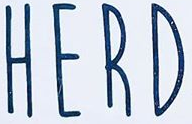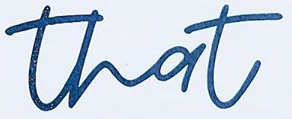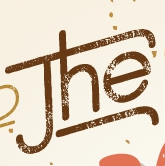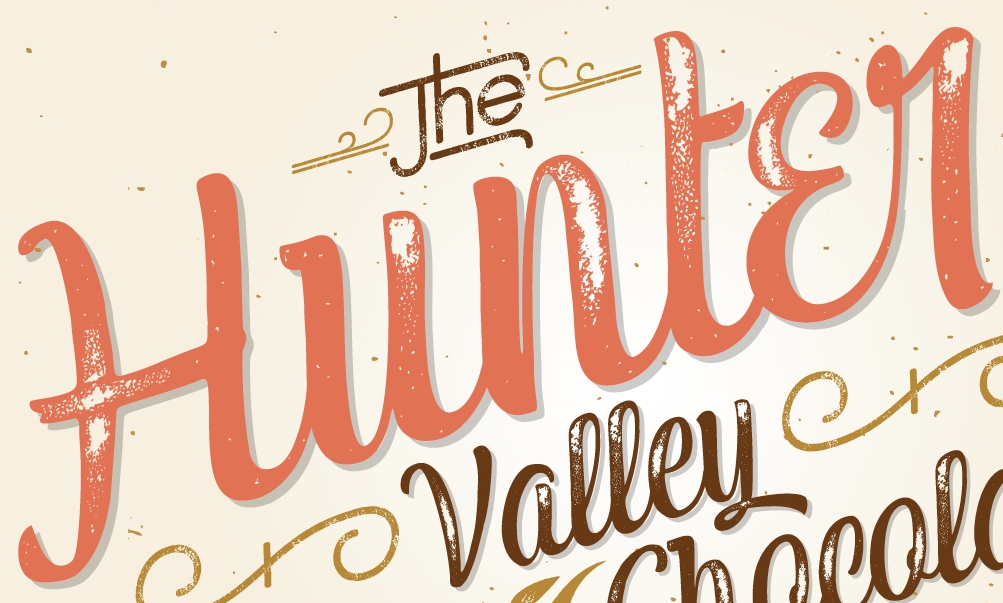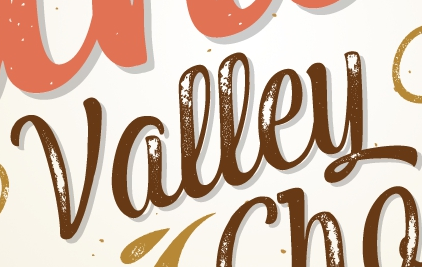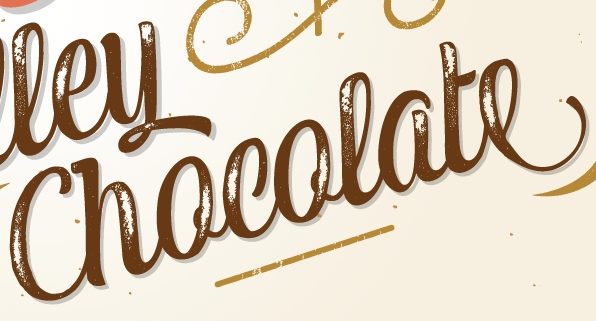Read the text from these images in sequence, separated by a semicolon. HERD; that; The; Hunter; Valley; Chocolate 